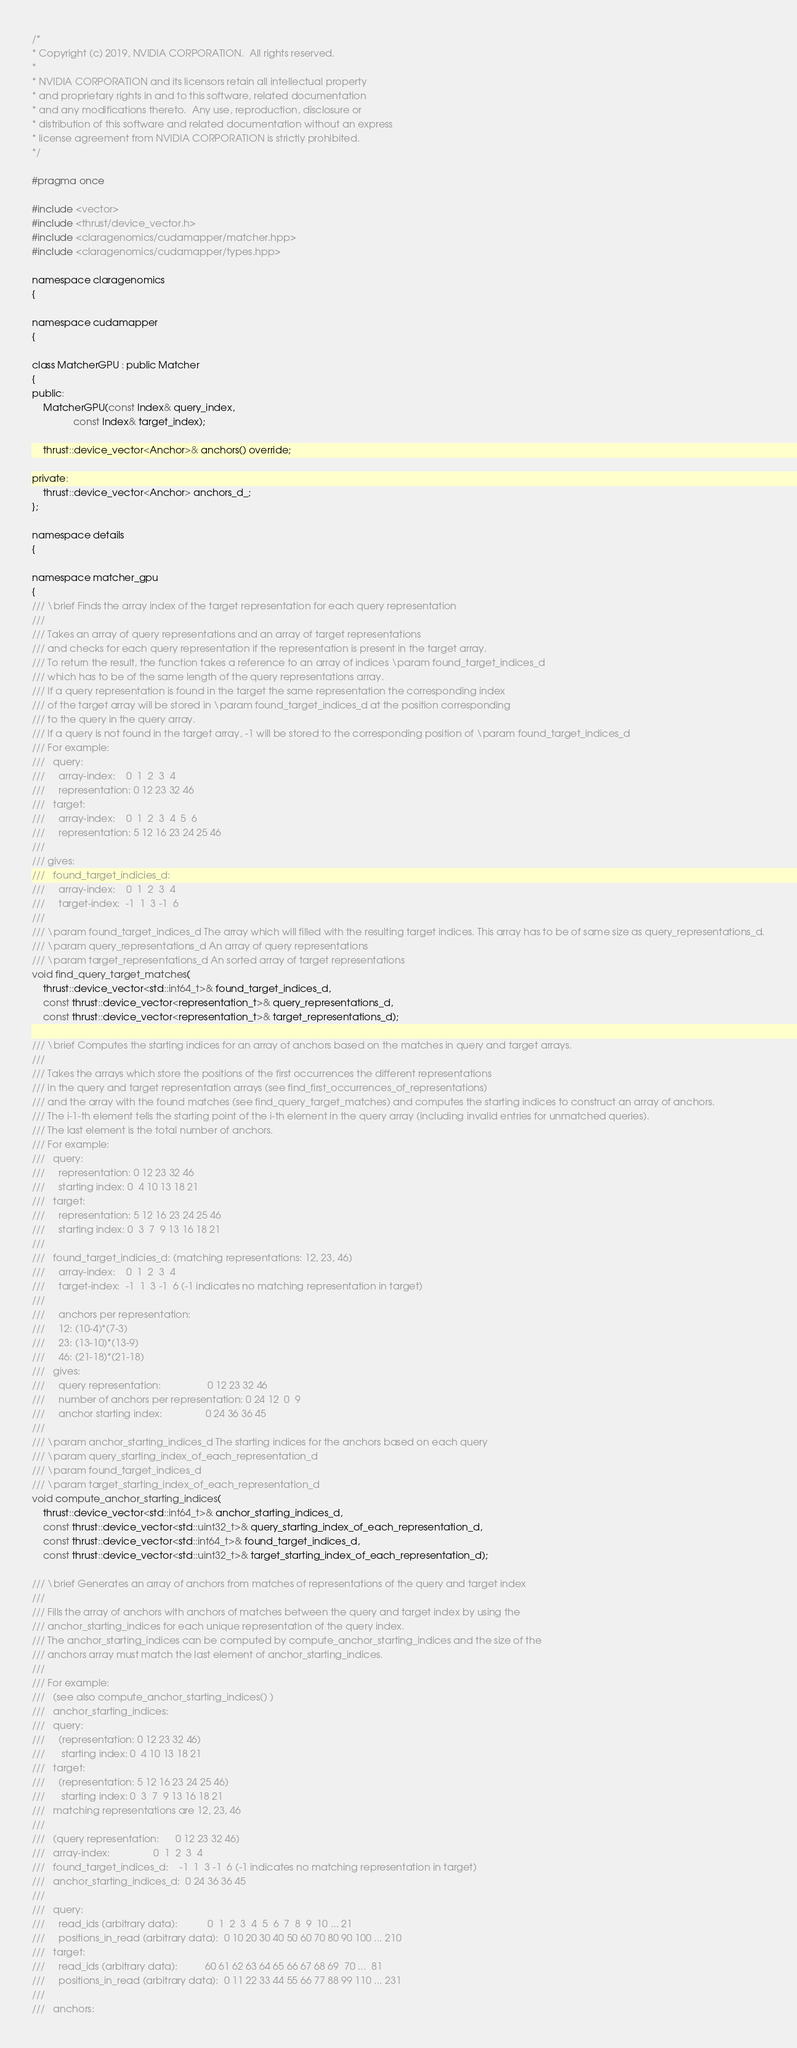Convert code to text. <code><loc_0><loc_0><loc_500><loc_500><_Cuda_>/*
* Copyright (c) 2019, NVIDIA CORPORATION.  All rights reserved.
*
* NVIDIA CORPORATION and its licensors retain all intellectual property
* and proprietary rights in and to this software, related documentation
* and any modifications thereto.  Any use, reproduction, disclosure or
* distribution of this software and related documentation without an express
* license agreement from NVIDIA CORPORATION is strictly prohibited.
*/

#pragma once

#include <vector>
#include <thrust/device_vector.h>
#include <claragenomics/cudamapper/matcher.hpp>
#include <claragenomics/cudamapper/types.hpp>

namespace claragenomics
{

namespace cudamapper
{

class MatcherGPU : public Matcher
{
public:
    MatcherGPU(const Index& query_index,
               const Index& target_index);

    thrust::device_vector<Anchor>& anchors() override;

private:
    thrust::device_vector<Anchor> anchors_d_;
};

namespace details
{

namespace matcher_gpu
{
/// \brief Finds the array index of the target representation for each query representation
///
/// Takes an array of query representations and an array of target representations
/// and checks for each query representation if the representation is present in the target array.
/// To return the result, the function takes a reference to an array of indices \param found_target_indices_d
/// which has to be of the same length of the query representations array.
/// If a query representation is found in the target the same representation the corresponding index
/// of the target array will be stored in \param found_target_indices_d at the position corresponding
/// to the query in the query array.
/// If a query is not found in the target array, -1 will be stored to the corresponding position of \param found_target_indices_d
/// For example:
///   query:
///     array-index:    0  1  2  3  4
///     representation: 0 12 23 32 46
///   target:
///     array-index:    0  1  2  3  4  5  6
///     representation: 5 12 16 23 24 25 46
///
/// gives:
///   found_target_indicies_d:
///     array-index:    0  1  2  3  4
///     target-index:  -1  1  3 -1  6
///
/// \param found_target_indices_d The array which will filled with the resulting target indices. This array has to be of same size as query_representations_d.
/// \param query_representations_d An array of query representations
/// \param target_representations_d An sorted array of target representations
void find_query_target_matches(
    thrust::device_vector<std::int64_t>& found_target_indices_d,
    const thrust::device_vector<representation_t>& query_representations_d,
    const thrust::device_vector<representation_t>& target_representations_d);

/// \brief Computes the starting indices for an array of anchors based on the matches in query and target arrays.
///
/// Takes the arrays which store the positions of the first occurrences the different representations
/// in the query and target representation arrays (see find_first_occurrences_of_representations)
/// and the array with the found matches (see find_query_target_matches) and computes the starting indices to construct an array of anchors.
/// The i-1-th element tells the starting point of the i-th element in the query array (including invalid entries for unmatched queries).
/// The last element is the total number of anchors.
/// For example:
///   query:
///     representation: 0 12 23 32 46
///     starting index: 0  4 10 13 18 21
///   target:
///     representation: 5 12 16 23 24 25 46
///     starting index: 0  3  7  9 13 16 18 21
///
///   found_target_indicies_d: (matching representations: 12, 23, 46)
///     array-index:    0  1  2  3  4
///     target-index:  -1  1  3 -1  6 (-1 indicates no matching representation in target)
///
///     anchors per representation:
///     12: (10-4)*(7-3)
///     23: (13-10)*(13-9)
///     46: (21-18)*(21-18)
///   gives:
///     query representation:                 0 12 23 32 46
///     number of anchors per representation: 0 24 12  0  9
///     anchor starting index:                0 24 36 36 45
///
/// \param anchor_starting_indices_d The starting indices for the anchors based on each query
/// \param query_starting_index_of_each_representation_d
/// \param found_target_indices_d
/// \param target_starting_index_of_each_representation_d
void compute_anchor_starting_indices(
    thrust::device_vector<std::int64_t>& anchor_starting_indices_d,
    const thrust::device_vector<std::uint32_t>& query_starting_index_of_each_representation_d,
    const thrust::device_vector<std::int64_t>& found_target_indices_d,
    const thrust::device_vector<std::uint32_t>& target_starting_index_of_each_representation_d);

/// \brief Generates an array of anchors from matches of representations of the query and target index
///
/// Fills the array of anchors with anchors of matches between the query and target index by using the
/// anchor_starting_indices for each unique representation of the query index.
/// The anchor_starting_indices can be computed by compute_anchor_starting_indices and the size of the
/// anchors array must match the last element of anchor_starting_indices.
///
/// For example:
///   (see also compute_anchor_starting_indices() )
///   anchor_starting_indices:
///   query:
///     (representation: 0 12 23 32 46)
///      starting index: 0  4 10 13 18 21
///   target:
///     (representation: 5 12 16 23 24 25 46)
///      starting index: 0  3  7  9 13 16 18 21
///   matching representations are 12, 23, 46
///
///   (query representation:      0 12 23 32 46)
///   array-index:                0  1  2  3  4
///   found_target_indices_d:    -1  1  3 -1  6 (-1 indicates no matching representation in target)
///   anchor_starting_indices_d:  0 24 36 36 45
///
///   query:
///     read_ids (arbitrary data):           0  1  2  3  4  5  6  7  8  9  10 ... 21
///     positions_in_read (arbitrary data):  0 10 20 30 40 50 60 70 80 90 100 ... 210
///   target:
///     read_ids (arbitrary data):          60 61 62 63 64 65 66 67 68 69  70 ...  81
///     positions_in_read (arbitrary data):  0 11 22 33 44 55 66 77 88 99 110 ... 231
///
///   anchors:</code> 